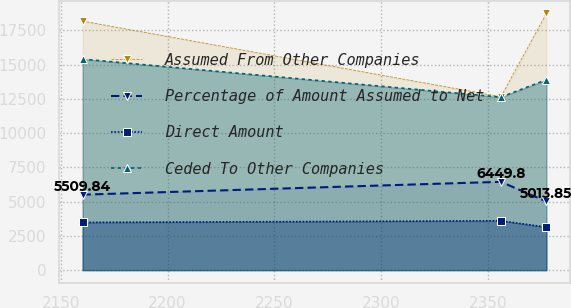Convert chart to OTSL. <chart><loc_0><loc_0><loc_500><loc_500><line_chart><ecel><fcel>Assumed From Other Companies<fcel>Percentage of Amount Assumed to Net<fcel>Direct Amount<fcel>Ceded To Other Companies<nl><fcel>2160.22<fcel>18182.9<fcel>5509.84<fcel>3483.7<fcel>15410.2<nl><fcel>2356.17<fcel>12661<fcel>6449.8<fcel>3600.43<fcel>12632<nl><fcel>2377.49<fcel>18744<fcel>5013.85<fcel>3136.65<fcel>13897.6<nl></chart> 